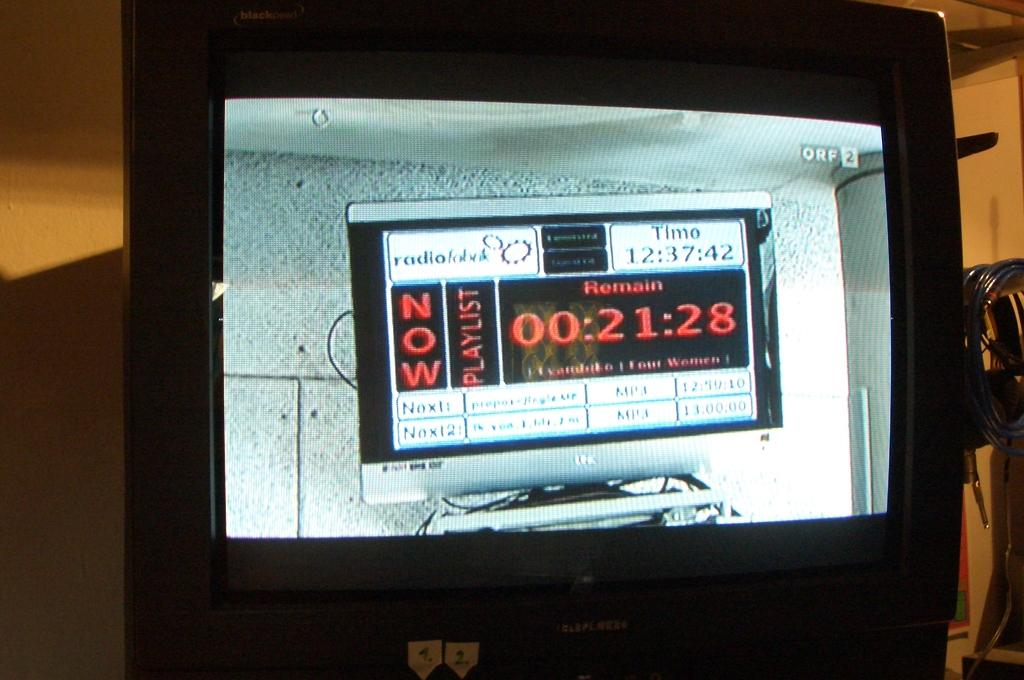<image>
Offer a succinct explanation of the picture presented. A TV screen with the words now and playlist on it 